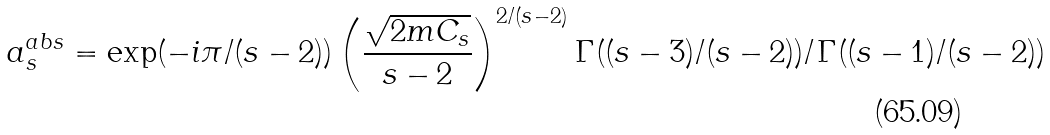<formula> <loc_0><loc_0><loc_500><loc_500>a ^ { a b s } _ { s } = \exp ( - i \pi / ( s - 2 ) ) \left ( \frac { \sqrt { 2 m C _ { s } } } { s - 2 } \right ) ^ { 2 / ( s - 2 ) } \Gamma ( ( s - 3 ) / ( s - 2 ) ) / \Gamma ( ( s - 1 ) / ( s - 2 ) )</formula> 